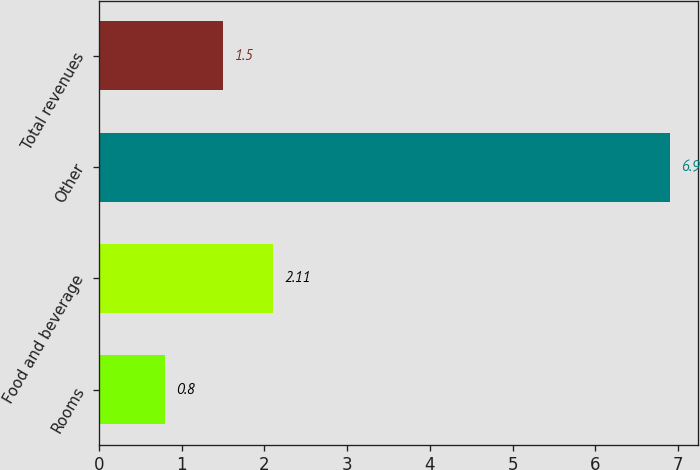Convert chart to OTSL. <chart><loc_0><loc_0><loc_500><loc_500><bar_chart><fcel>Rooms<fcel>Food and beverage<fcel>Other<fcel>Total revenues<nl><fcel>0.8<fcel>2.11<fcel>6.9<fcel>1.5<nl></chart> 